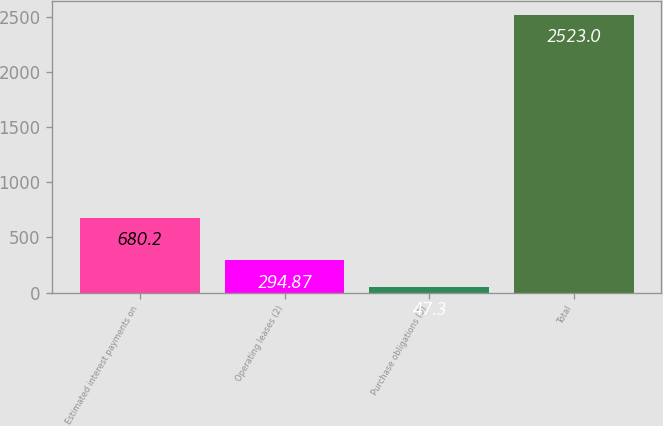Convert chart. <chart><loc_0><loc_0><loc_500><loc_500><bar_chart><fcel>Estimated interest payments on<fcel>Operating leases (2)<fcel>Purchase obligations (3)<fcel>Total<nl><fcel>680.2<fcel>294.87<fcel>47.3<fcel>2523<nl></chart> 